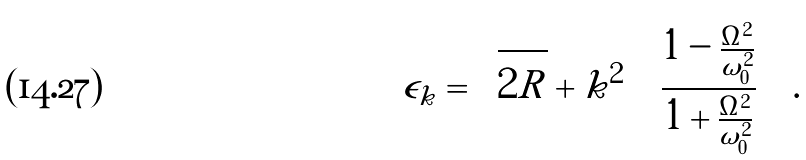Convert formula to latex. <formula><loc_0><loc_0><loc_500><loc_500>\epsilon _ { k } = \sqrt { 2 R } + k ^ { 2 } \left ( \frac { 1 - \frac { \Omega ^ { 2 } } { \omega _ { 0 } ^ { 2 } } } { 1 + \frac { \Omega ^ { 2 } } { \omega _ { 0 } ^ { 2 } } } \right ) .</formula> 